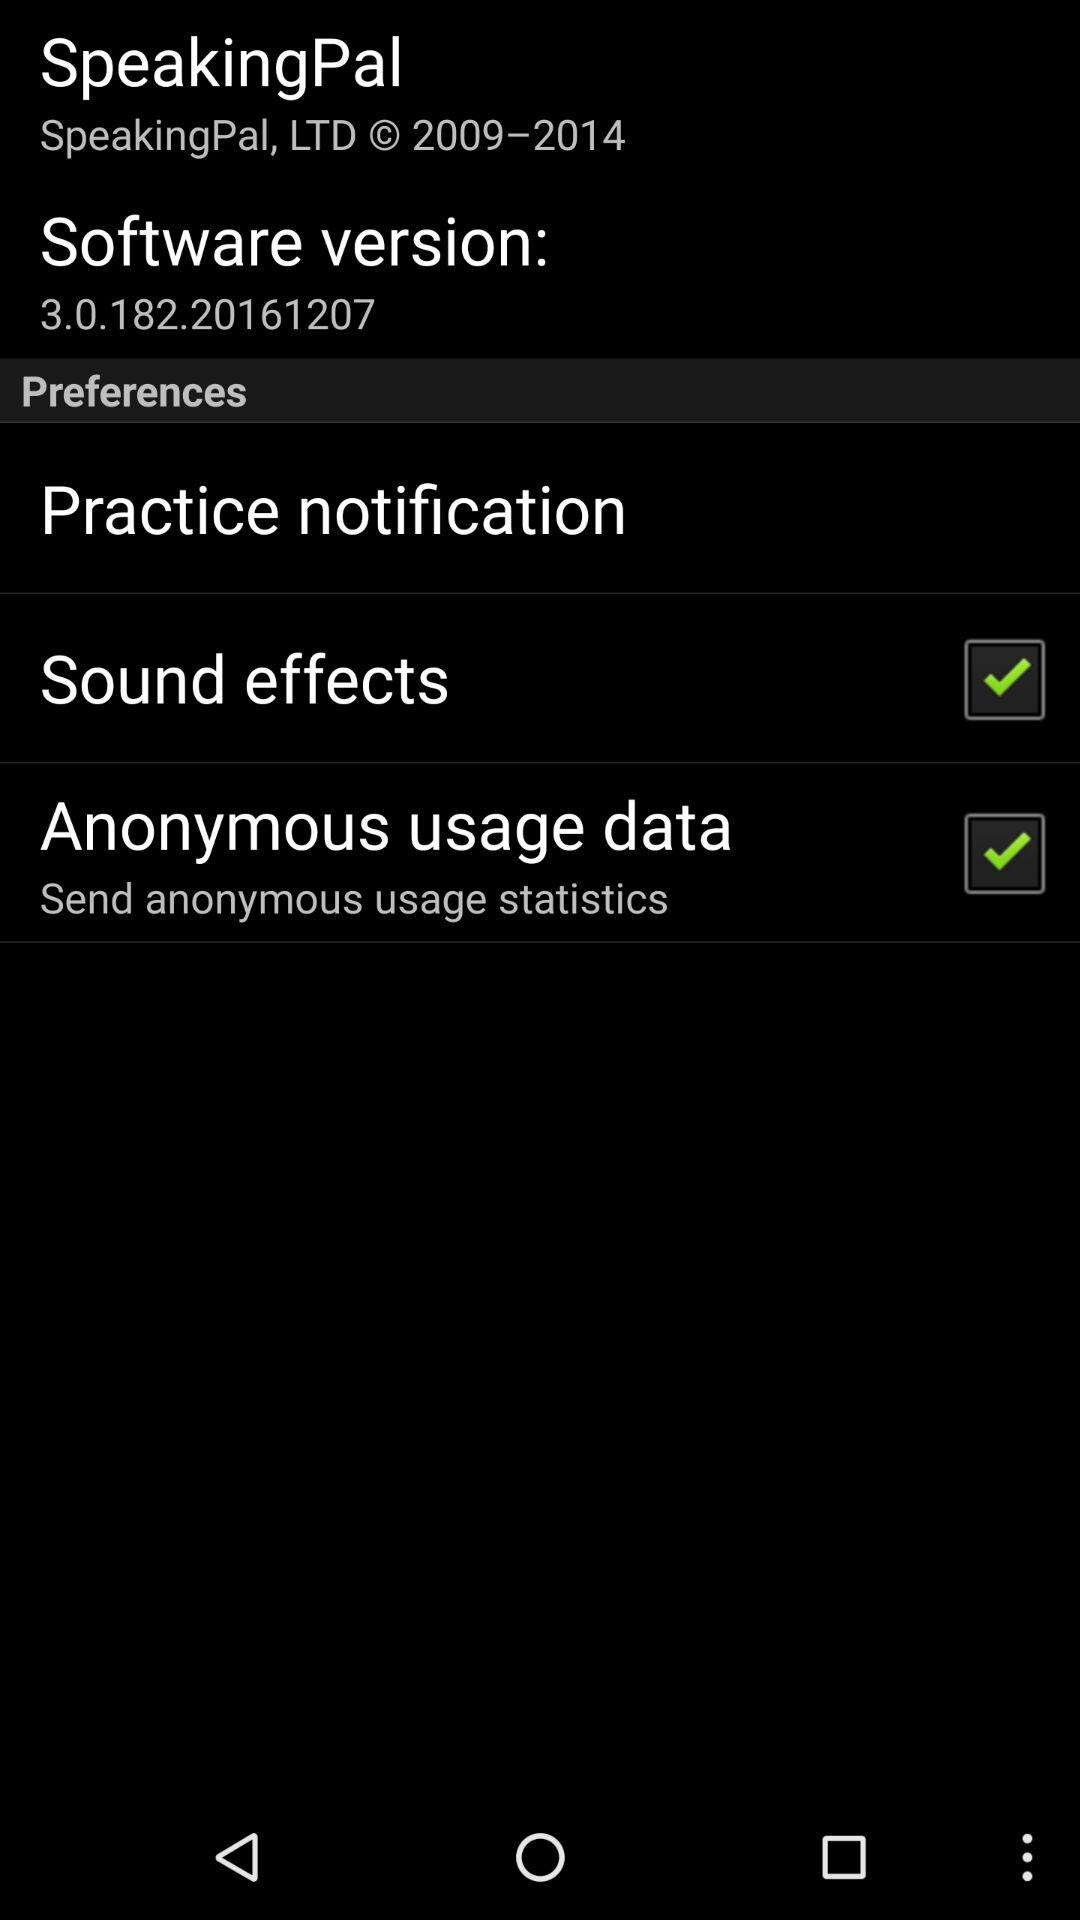How many items have a check box?
Answer the question using a single word or phrase. 2 